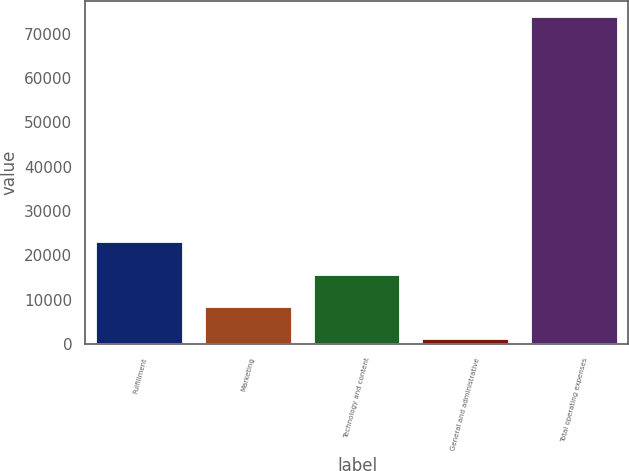Convert chart to OTSL. <chart><loc_0><loc_0><loc_500><loc_500><bar_chart><fcel>Fulfillment<fcel>Marketing<fcel>Technology and content<fcel>General and administrative<fcel>Total operating expenses<nl><fcel>22902.4<fcel>8386.8<fcel>15644.6<fcel>1129<fcel>73707<nl></chart> 